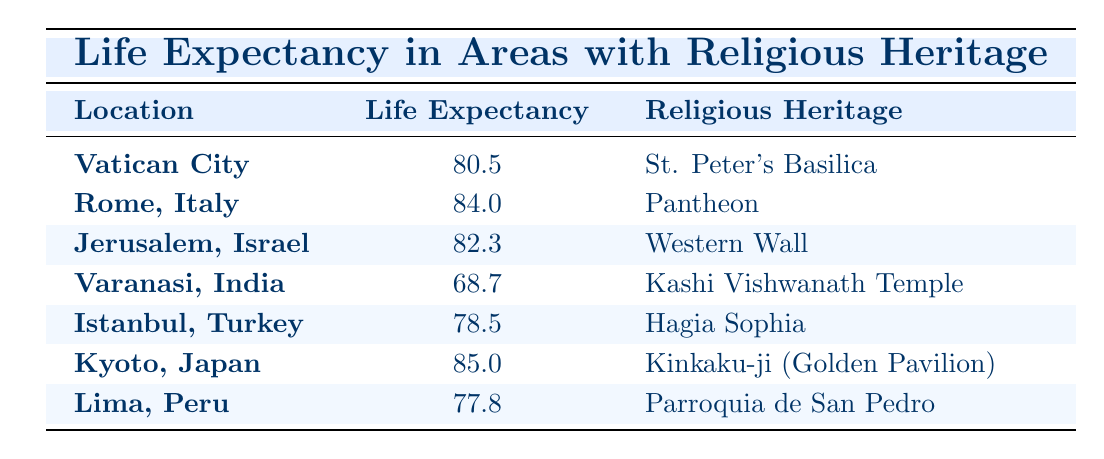What is the average life expectancy in Rome, Italy? The table shows that the average life expectancy in Rome, Italy is listed as 84.0.
Answer: 84.0 Which location has the highest average life expectancy? By comparing the life expectancy values, Kyoto, Japan has the highest average at 85.0.
Answer: Kyoto, Japan What is the difference in life expectancy between Jerusalem, Israel, and Varanasi, India? The average life expectancy in Jerusalem is 82.3 and in Varanasi it is 68.7. The difference is calculated as 82.3 - 68.7 = 13.6.
Answer: 13.6 Is the average life expectancy in Istanbul, Turkey greater than 80% of that in Vatican City? Vatican City's life expectancy is 80.5. 80% of that is calculated as 0.8 * 80.5 = 64.4. Since Istanbul's life expectancy is 78.5, which is greater than 64.4, the answer is yes.
Answer: Yes What is the total average life expectancy of all the locations listed? The average life expectancies are 80.5, 84.0, 82.3, 68.7, 78.5, 85.0, and 77.8. Summing these gives us a total of 80.5 + 84.0 + 82.3 + 68.7 + 78.5 + 85.0 + 77.8 = 577.8.
Answer: 577.8 How many locations have a life expectancy above 80 years? The locations with an average life expectancy above 80 years are Vatican City (80.5), Rome (84.0), Jerusalem (82.3), and Kyoto (85.0), a total of 4 locations.
Answer: 4 Is the significance of the religious heritage correlated with life expectancy in these locations? A thorough analysis would require assessing each location's heritage and comparing the life expectancy values. However, at a glance, the highest life expectancies are seen in areas with strong religious heritage like Kyoto, Rome, and Jerusalem, so one can argue there may be a positive correlation. Detailed data analysis would be needed for confirmation.
Answer: Cannot determine without further analysis What is the average life expectancy of locations with significant religious heritage compared to those without? The data only includes locations with significant religious heritage, making it impossible to compare. There is no information provided on locations without such heritage.
Answer: Not available for comparison 